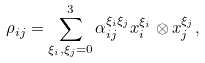<formula> <loc_0><loc_0><loc_500><loc_500>\rho _ { i j } = \sum _ { \xi _ { i } , \xi _ { j } = 0 } ^ { 3 } \alpha _ { i j } ^ { \xi _ { i } \xi _ { j } } x _ { i } ^ { \xi _ { i } } \otimes x _ { j } ^ { \xi _ { j } } ,</formula> 